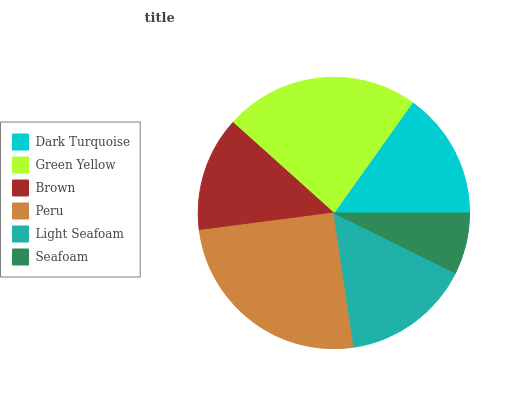Is Seafoam the minimum?
Answer yes or no. Yes. Is Peru the maximum?
Answer yes or no. Yes. Is Green Yellow the minimum?
Answer yes or no. No. Is Green Yellow the maximum?
Answer yes or no. No. Is Green Yellow greater than Dark Turquoise?
Answer yes or no. Yes. Is Dark Turquoise less than Green Yellow?
Answer yes or no. Yes. Is Dark Turquoise greater than Green Yellow?
Answer yes or no. No. Is Green Yellow less than Dark Turquoise?
Answer yes or no. No. Is Light Seafoam the high median?
Answer yes or no. Yes. Is Dark Turquoise the low median?
Answer yes or no. Yes. Is Peru the high median?
Answer yes or no. No. Is Brown the low median?
Answer yes or no. No. 